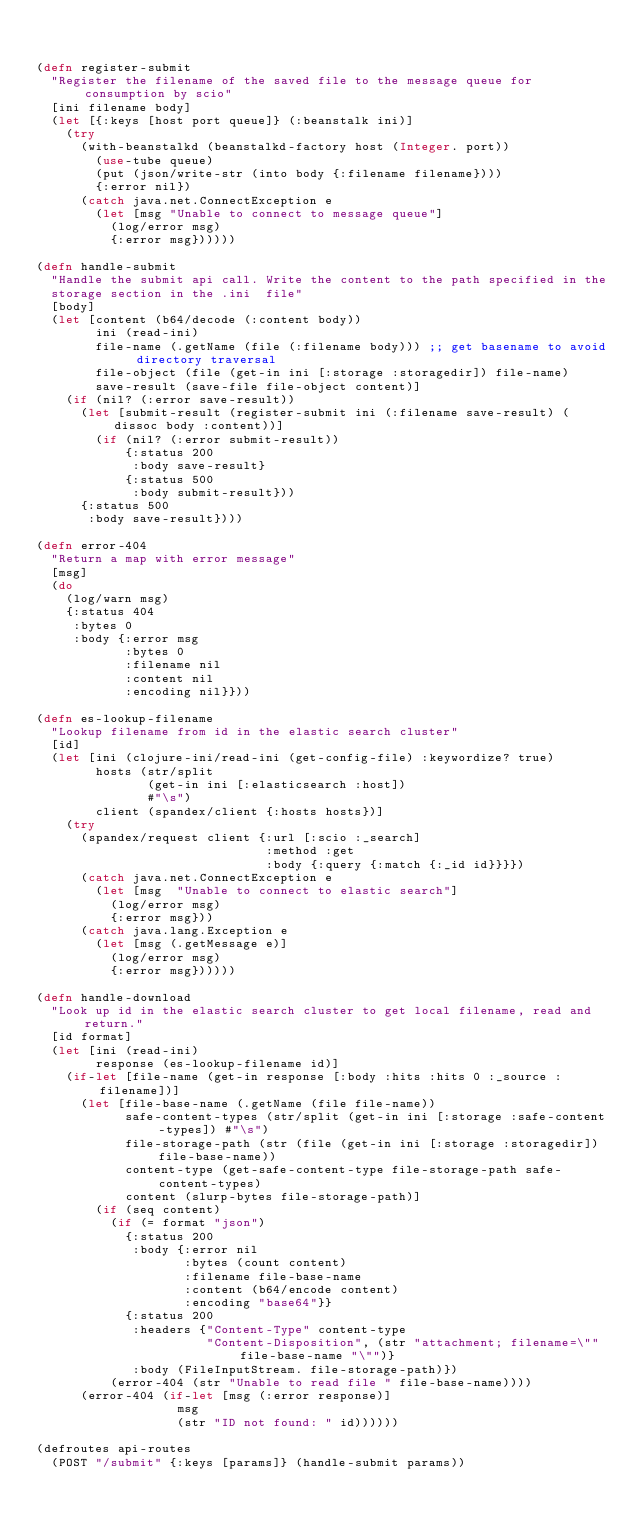Convert code to text. <code><loc_0><loc_0><loc_500><loc_500><_Clojure_>

(defn register-submit
  "Register the filename of the saved file to the message queue for consumption by scio"
  [ini filename body]
  (let [{:keys [host port queue]} (:beanstalk ini)]
    (try
      (with-beanstalkd (beanstalkd-factory host (Integer. port))
        (use-tube queue)
        (put (json/write-str (into body {:filename filename})))
        {:error nil})
      (catch java.net.ConnectException e
        (let [msg "Unable to connect to message queue"]
          (log/error msg)
          {:error msg})))))

(defn handle-submit
  "Handle the submit api call. Write the content to the path specified in the
  storage section in the .ini  file"
  [body]
  (let [content (b64/decode (:content body))
        ini (read-ini)
        file-name (.getName (file (:filename body))) ;; get basename to avoid directory traversal
        file-object (file (get-in ini [:storage :storagedir]) file-name)
        save-result (save-file file-object content)]
    (if (nil? (:error save-result))
      (let [submit-result (register-submit ini (:filename save-result) (dissoc body :content))]
        (if (nil? (:error submit-result))
            {:status 200
             :body save-result}
            {:status 500
             :body submit-result}))
      {:status 500
       :body save-result})))

(defn error-404
  "Return a map with error message"
  [msg]
  (do
    (log/warn msg)
    {:status 404
     :bytes 0
     :body {:error msg
            :bytes 0
            :filename nil
            :content nil
            :encoding nil}}))

(defn es-lookup-filename
  "Lookup filename from id in the elastic search cluster"
  [id]
  (let [ini (clojure-ini/read-ini (get-config-file) :keywordize? true)
        hosts (str/split
               (get-in ini [:elasticsearch :host])
               #"\s")
        client (spandex/client {:hosts hosts})]
    (try
      (spandex/request client {:url [:scio :_search]
                               :method :get
                               :body {:query {:match {:_id id}}}})
      (catch java.net.ConnectException e
        (let [msg  "Unable to connect to elastic search"]
          (log/error msg)
          {:error msg}))
      (catch java.lang.Exception e
        (let [msg (.getMessage e)]
          (log/error msg)
          {:error msg})))))

(defn handle-download
  "Look up id in the elastic search cluster to get local filename, read and return."
  [id format]
  (let [ini (read-ini)
        response (es-lookup-filename id)]
    (if-let [file-name (get-in response [:body :hits :hits 0 :_source :filename])]
      (let [file-base-name (.getName (file file-name))
            safe-content-types (str/split (get-in ini [:storage :safe-content-types]) #"\s")
            file-storage-path (str (file (get-in ini [:storage :storagedir]) file-base-name))
            content-type (get-safe-content-type file-storage-path safe-content-types)
            content (slurp-bytes file-storage-path)]
        (if (seq content)
          (if (= format "json")
            {:status 200
             :body {:error nil
                    :bytes (count content)
                    :filename file-base-name
                    :content (b64/encode content)
                    :encoding "base64"}}
            {:status 200
             :headers {"Content-Type" content-type
                       "Content-Disposition", (str "attachment; filename=\"" file-base-name "\"")}
             :body (FileInputStream. file-storage-path)})
          (error-404 (str "Unable to read file " file-base-name))))
      (error-404 (if-let [msg (:error response)]
                   msg
                   (str "ID not found: " id))))))

(defroutes api-routes
  (POST "/submit" {:keys [params]} (handle-submit params))</code> 